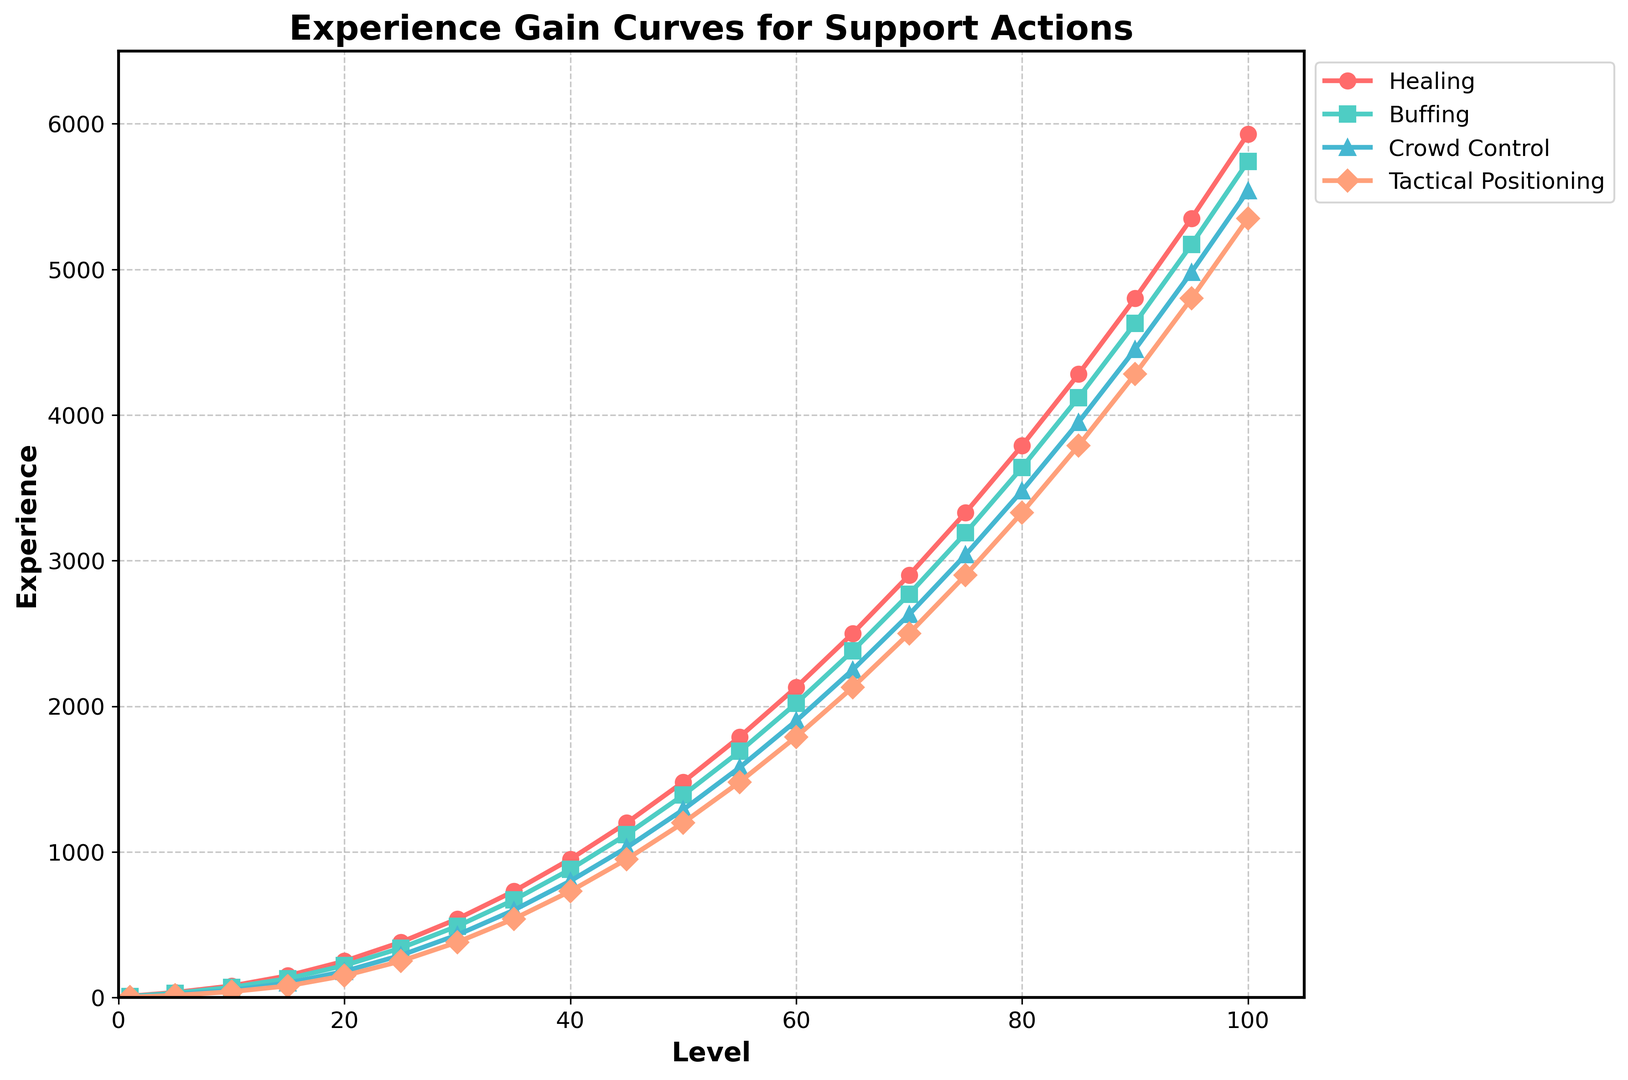What is the experience gain for Tactical Positioning at level 50 compared to Buffing at level 50? From the plot, the experience gain for Tactical Positioning at level 50 is around 1200, while for Buffing, it is around 1390. The difference is 1390 - 1200 = 190
Answer: 190 Among the four actions, which action has the highest experience gain at level 70? Looking at the curves for level 70, Buffing has the highest experience gain at that level, with an experience value of approximately 2770
Answer: Buffing Which support action experiences the greatest increment in experience gain from level 15 to level 20? From level 15 to level 20, the increment for Healing is 250 - 150 = 100, Buffing is 220 - 130 = 90, Crowd Control is 180 - 100 = 80, and Tactical Positioning is 150 - 80 = 70. Healing has the greatest increment.
Answer: Healing Determine the average experience gain for Crowd Control across levels 1, 25, and 50 The experience gains for Crowd Control at levels 1, 25, and 50 are 5, 290, and 1290, respectively. The average is (5 + 290 + 1290)/3 = 1585/3 ≈ 528.33
Answer: 528.33 At which level does Buffing first reach 1000 experience points? Refer to the curve, Buffing first reaches around 1000 experience points between level 40 and 45. Interpolating, it appears to be approximately level 42
Answer: Approximately level 42 How does the experience gain for Healing at level 95 compare to that of Tactical Positioning at level 90? The experience gain for Healing at level 95 is around 5350, while for Tactical Positioning at level 90 it is around 4280. Hence, Healing at level 95 has higher experience.
Answer: Healing at level 95 What is the ratio of Healing experience gain at level 60 to Buffing experience gain at level 60? The experience gain for Healing at level 60 is 2130, and for Buffing, it is 2020. The ratio is 2130/2020 = 1.0545
Answer: 1.0545 What is the sum of experience gains for Tactical Positioning and Crowd Control at level 75? The experience gain for Tactical Positioning at level 75 is around 2900, and for Crowd Control it is around 3040. The sum is 2900 + 3040 = 5940
Answer: 5940 